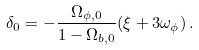Convert formula to latex. <formula><loc_0><loc_0><loc_500><loc_500>\delta _ { 0 } = - \frac { \Omega _ { \phi , 0 } } { 1 - \Omega _ { b , 0 } } ( \xi + 3 \omega _ { \phi } ) \, .</formula> 